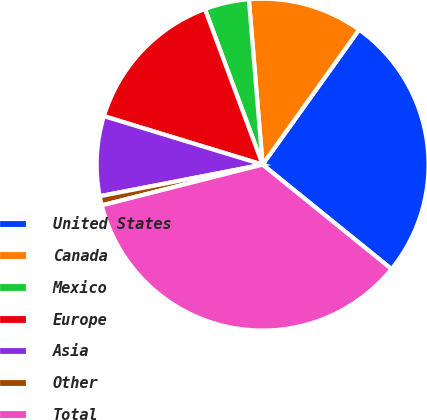Convert chart. <chart><loc_0><loc_0><loc_500><loc_500><pie_chart><fcel>United States<fcel>Canada<fcel>Mexico<fcel>Europe<fcel>Asia<fcel>Other<fcel>Total<nl><fcel>25.96%<fcel>11.2%<fcel>4.33%<fcel>14.63%<fcel>7.77%<fcel>0.9%<fcel>35.21%<nl></chart> 